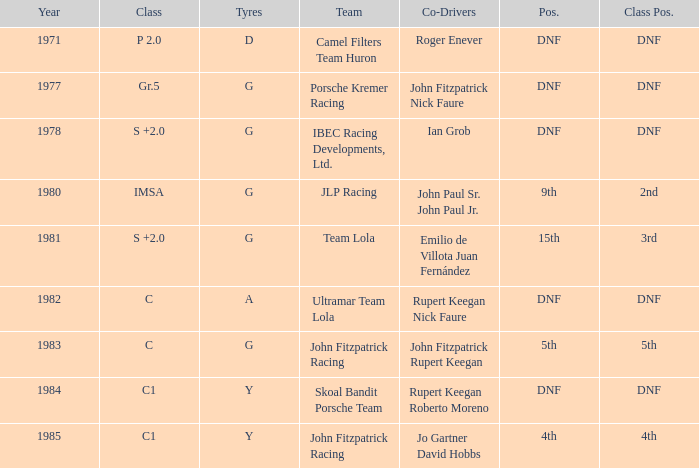Which tires were in Class C in years before 1983? A. 